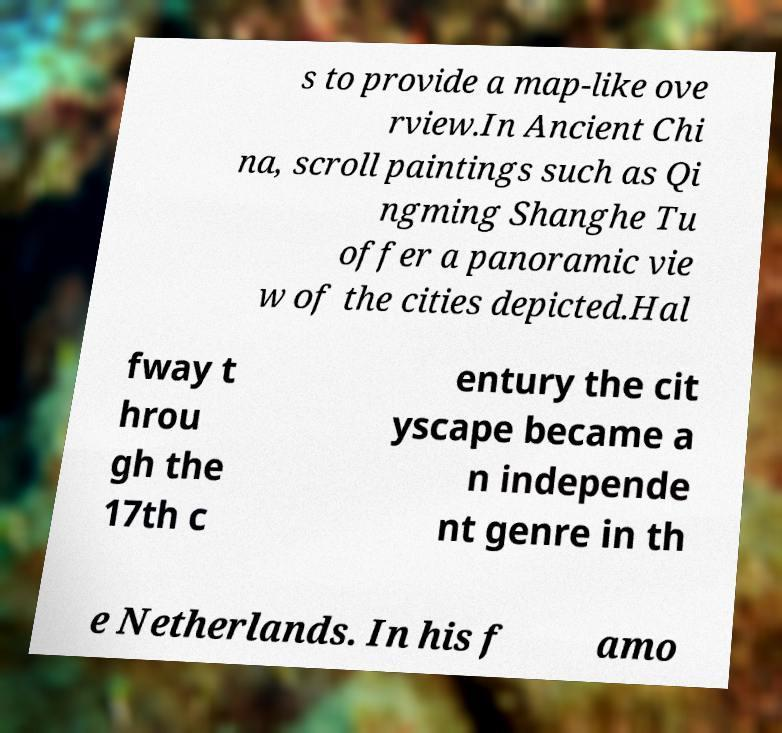What messages or text are displayed in this image? I need them in a readable, typed format. s to provide a map-like ove rview.In Ancient Chi na, scroll paintings such as Qi ngming Shanghe Tu offer a panoramic vie w of the cities depicted.Hal fway t hrou gh the 17th c entury the cit yscape became a n independe nt genre in th e Netherlands. In his f amo 